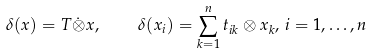<formula> <loc_0><loc_0><loc_500><loc_500>\delta ( x ) = T \dot { \otimes } x , \quad \delta ( x _ { i } ) = \sum ^ { n } _ { k = 1 } t _ { i k } \otimes x _ { k } , \, i = 1 , \dots , n</formula> 